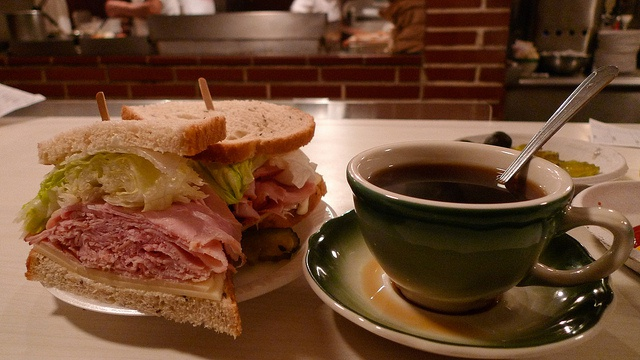Describe the objects in this image and their specific colors. I can see dining table in black, maroon, brown, and tan tones, sandwich in black, brown, and maroon tones, cup in black, maroon, and tan tones, sandwich in black, maroon, and tan tones, and spoon in black, maroon, and gray tones in this image. 